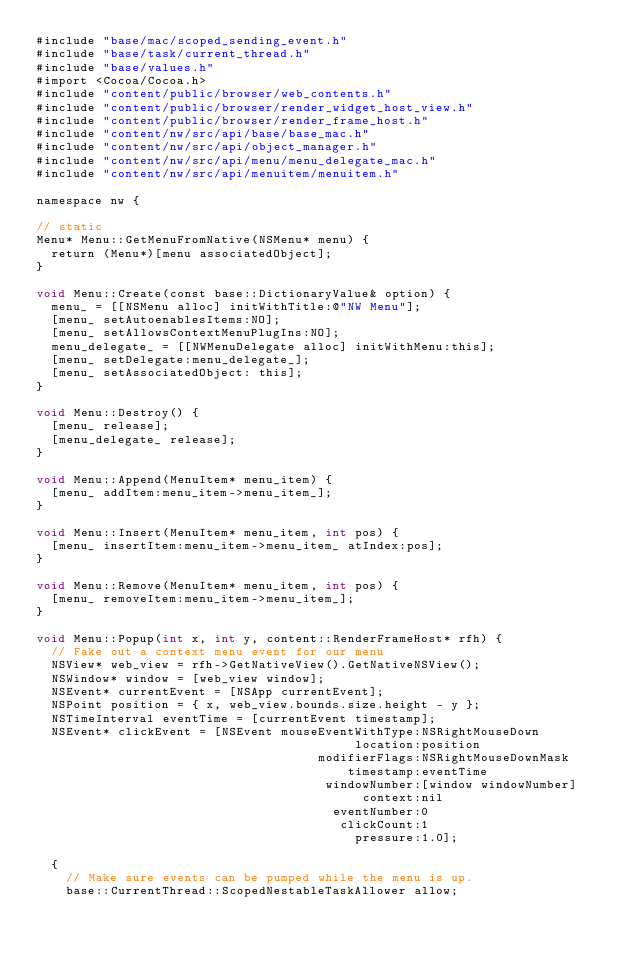<code> <loc_0><loc_0><loc_500><loc_500><_ObjectiveC_>#include "base/mac/scoped_sending_event.h"
#include "base/task/current_thread.h"
#include "base/values.h"
#import <Cocoa/Cocoa.h>
#include "content/public/browser/web_contents.h"
#include "content/public/browser/render_widget_host_view.h"
#include "content/public/browser/render_frame_host.h"
#include "content/nw/src/api/base/base_mac.h"
#include "content/nw/src/api/object_manager.h"
#include "content/nw/src/api/menu/menu_delegate_mac.h"
#include "content/nw/src/api/menuitem/menuitem.h"

namespace nw {

// static
Menu* Menu::GetMenuFromNative(NSMenu* menu) {
  return (Menu*)[menu associatedObject];
}

void Menu::Create(const base::DictionaryValue& option) {
  menu_ = [[NSMenu alloc] initWithTitle:@"NW Menu"];
  [menu_ setAutoenablesItems:NO];
  [menu_ setAllowsContextMenuPlugIns:NO];
  menu_delegate_ = [[NWMenuDelegate alloc] initWithMenu:this];
  [menu_ setDelegate:menu_delegate_];
  [menu_ setAssociatedObject: this];
}

void Menu::Destroy() {
  [menu_ release];
  [menu_delegate_ release];
}

void Menu::Append(MenuItem* menu_item) {
  [menu_ addItem:menu_item->menu_item_];
}

void Menu::Insert(MenuItem* menu_item, int pos) {
  [menu_ insertItem:menu_item->menu_item_ atIndex:pos];
}

void Menu::Remove(MenuItem* menu_item, int pos) {
  [menu_ removeItem:menu_item->menu_item_];
}

void Menu::Popup(int x, int y, content::RenderFrameHost* rfh) {
  // Fake out a context menu event for our menu
  NSView* web_view = rfh->GetNativeView().GetNativeNSView();
  NSWindow* window = [web_view window];
  NSEvent* currentEvent = [NSApp currentEvent];
  NSPoint position = { x, web_view.bounds.size.height - y };
  NSTimeInterval eventTime = [currentEvent timestamp];
  NSEvent* clickEvent = [NSEvent mouseEventWithType:NSRightMouseDown
                                           location:position
                                      modifierFlags:NSRightMouseDownMask
                                          timestamp:eventTime
                                       windowNumber:[window windowNumber]
                                            context:nil
                                        eventNumber:0
                                         clickCount:1
                                           pressure:1.0];

  {
    // Make sure events can be pumped while the menu is up.
    base::CurrentThread::ScopedNestableTaskAllower allow;
</code> 